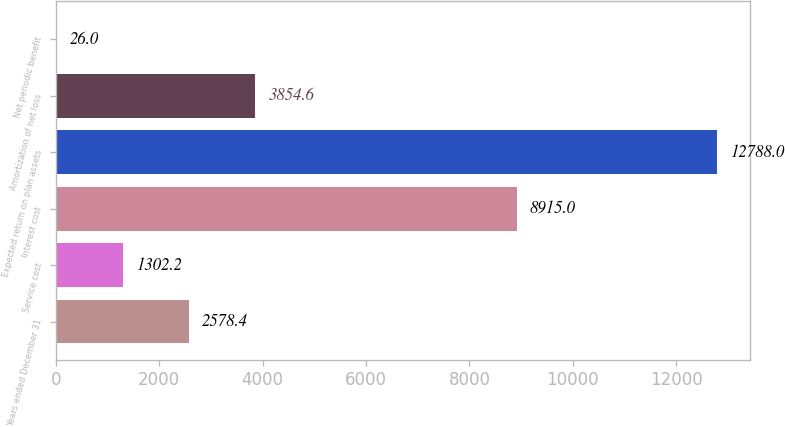Convert chart. <chart><loc_0><loc_0><loc_500><loc_500><bar_chart><fcel>Years ended December 31<fcel>Service cost<fcel>Interest cost<fcel>Expected return on plan assets<fcel>Amortization of net loss<fcel>Net periodic benefit<nl><fcel>2578.4<fcel>1302.2<fcel>8915<fcel>12788<fcel>3854.6<fcel>26<nl></chart> 